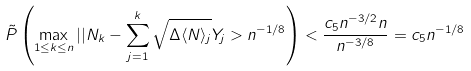<formula> <loc_0><loc_0><loc_500><loc_500>\tilde { P } \left ( \max _ { 1 \leq k \leq n } | | N _ { k } - \sum _ { j = 1 } ^ { k } \sqrt { \Delta \langle N \rangle _ { j } } Y _ { j } > n ^ { - 1 / 8 } \right ) < \frac { c _ { 5 } n ^ { - 3 / 2 } n } { n ^ { - 3 / 8 } } = c _ { 5 } n ^ { - 1 / 8 }</formula> 